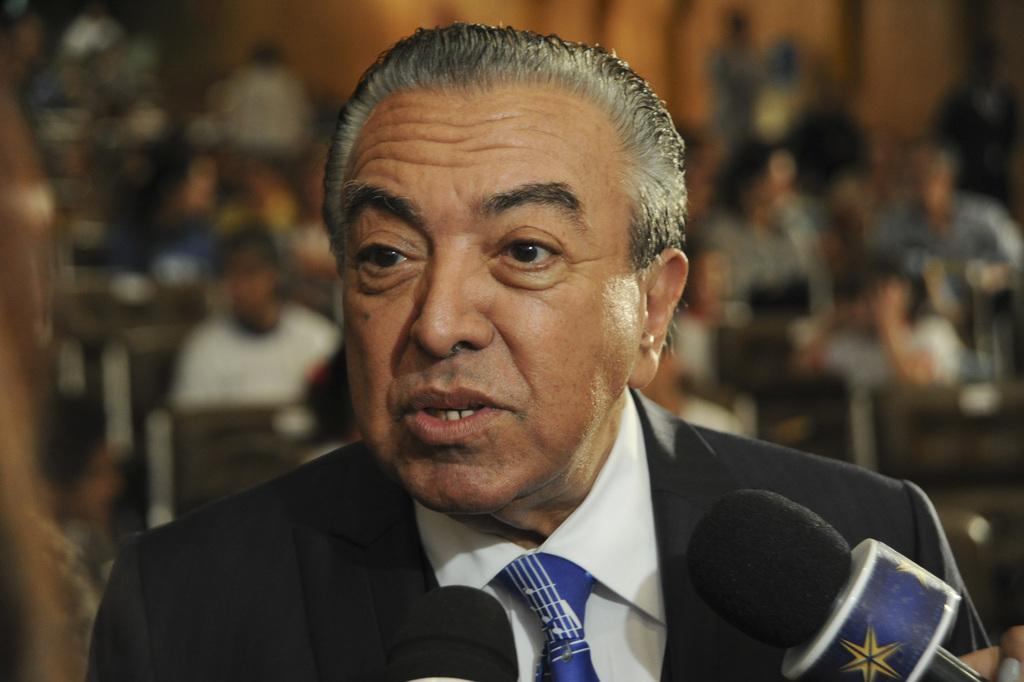What is the main subject of the image? There is a person in the image. What is the person wearing on their upper body? The person is wearing a black blazer, a white shirt, and a blue color tie. What object is visible in the image that is typically used for amplifying sound? There is a microphone in the image. Can you describe the background of the image? The background of the image is blurred. What type of cork can be seen in the image? There is no cork present in the image. How many parts of the person's body are visible in the image? The question is not relevant to the image, as it focuses on the number of body parts rather than the visible details. 